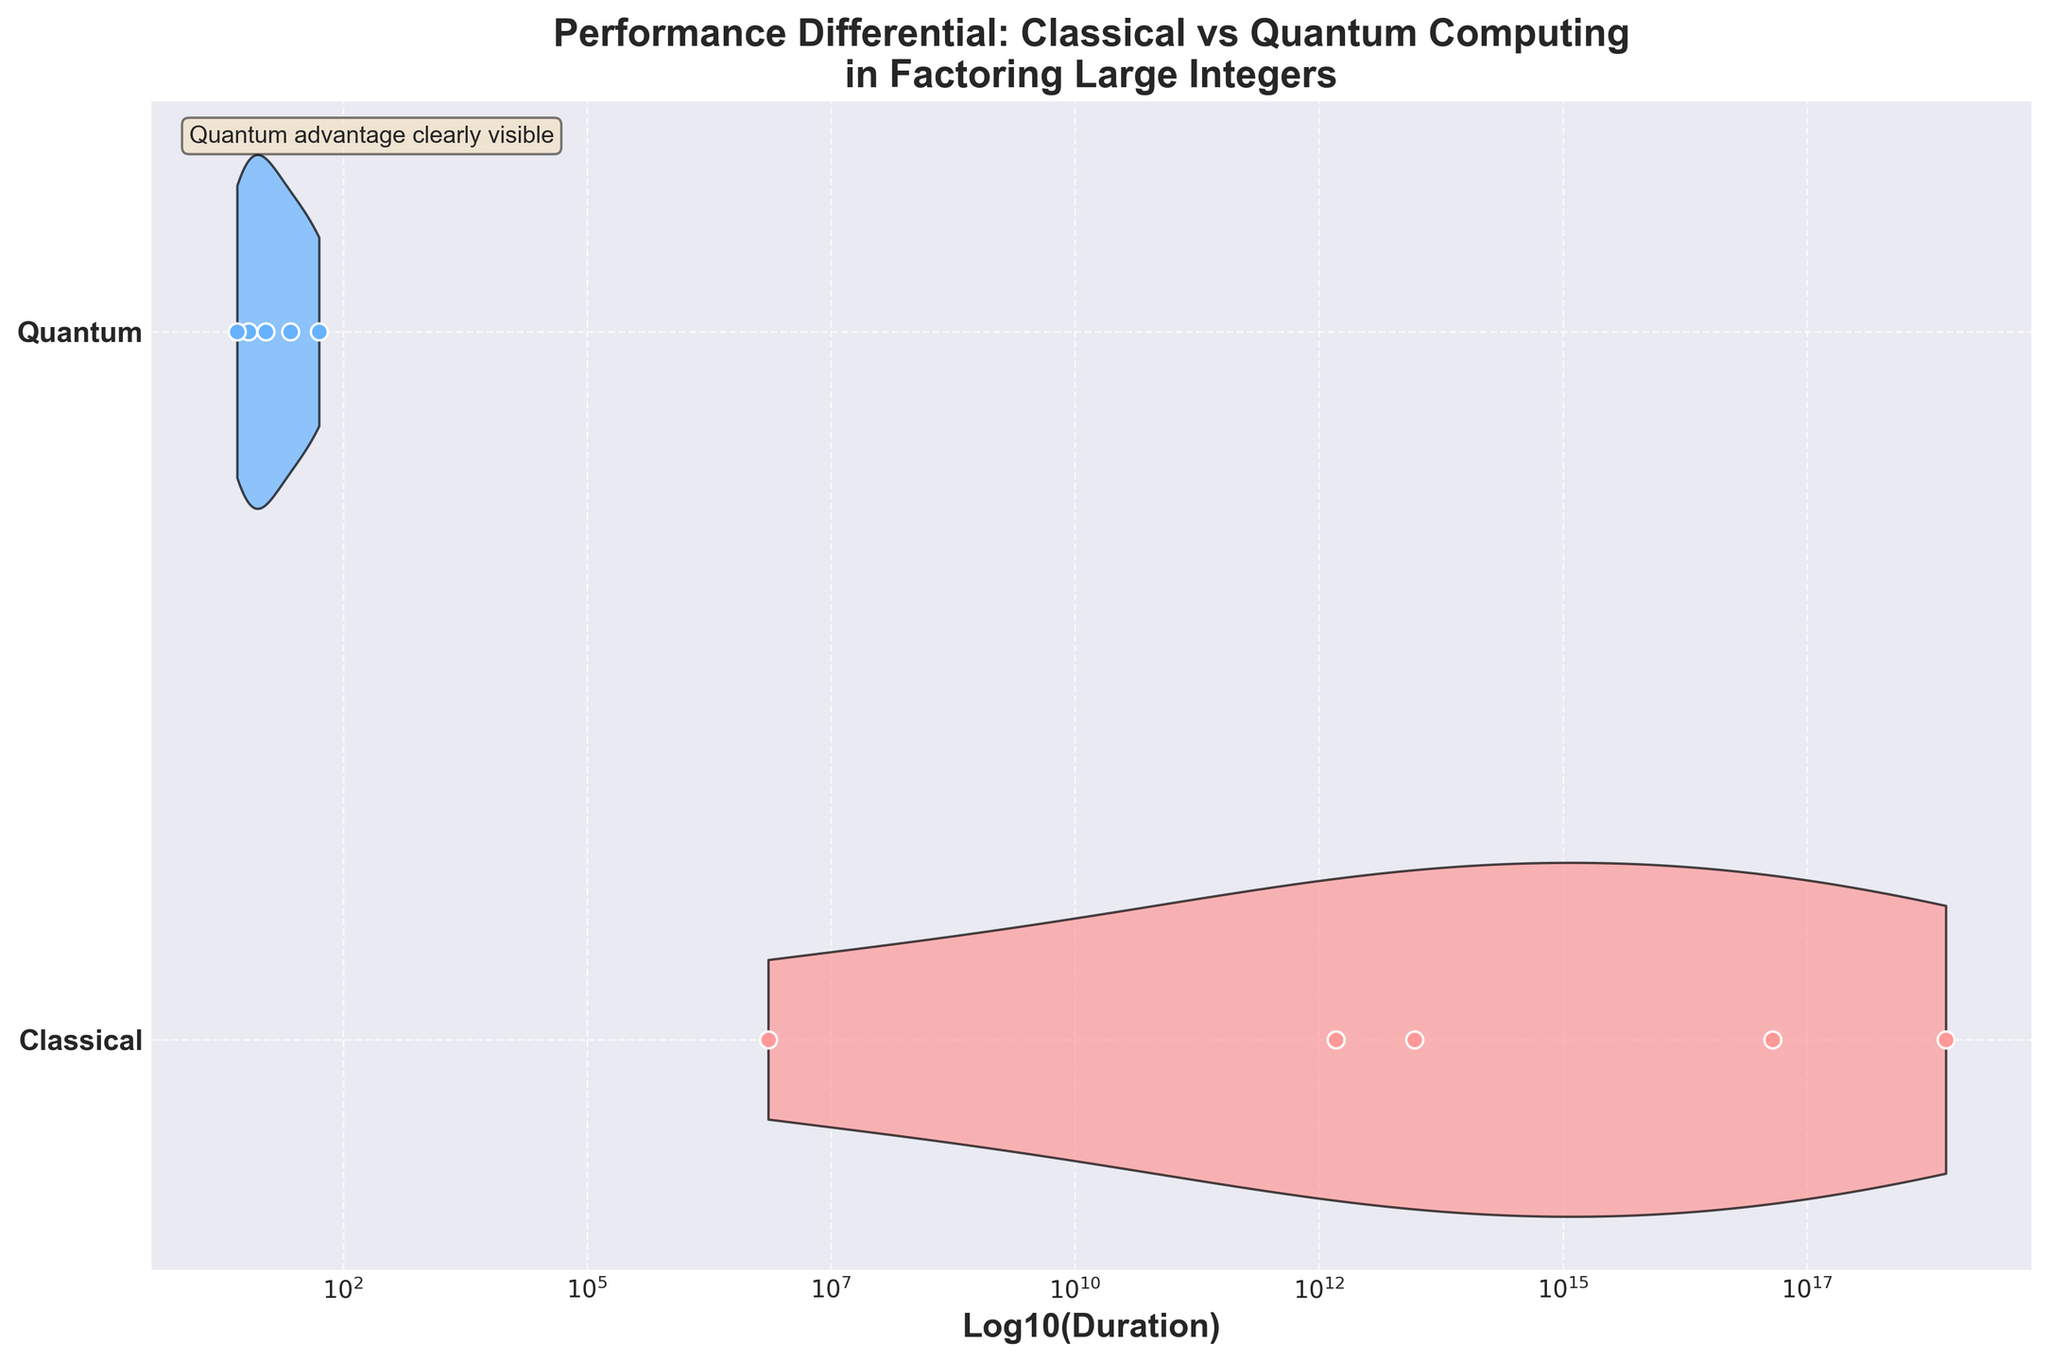What does the y-axis represent? The y-axis of the plot represents the two systems being compared: Classical and Quantum computing. Each system is assigned a specific position (1 for Classical, 2 for Quantum). The labels for these systems are marked on the y-axis.
Answer: Classical and Quantum systems What does the x-axis represent? The x-axis of the plot represents the logarithm (base 10) of the duration it takes for the systems to factor large integers. The values are shown in scientific notation for easier interpretation of large differences.
Answer: Logarithm of duration What colors are used to represent Classical and Quantum systems? The Classical system is represented by a light red (pinkish) color in the violin plot, while the Quantum system is represented by a light blue color. These colors help distinguish between the two systems easily.
Answer: Light red for Classical, light blue for Quantum Which system shows a clear advantage in factoring large integers, based on the plot? Based on the plot, the Quantum system has a clear advantage as the median log duration for Quantum computing is significantly lower than that for Classical computing, indicating that Quantum computing performs factoring much faster.
Answer: Quantum system How many distinct data points are represented for each system? Looking at the scatter plots overlaid on the violins, there are five distinct data points each for both Classical and Quantum systems.
Answer: Five for Classical, five for Quantum What is the range of log durations for the Classical system? The range of log durations for the Classical system can be seen from the scatter plot overlay on the violin. The lowest log duration is between 6 and 7, and the highest log duration is approximately 18.
Answer: Approximately 6 to 18 What is the approximate median duration for the Quantum system? The median duration for the Quantum system is where the bulk of the density of the violin plot is centered. It appears to be around 1.6 to 2 on the log scale.
Answer: 1.6 to 2 on the log scale How much faster is Quantum computing compared to Classical computing for factoring large integers? To contextualize this, consider the log duration ranges: the Quantum computing durations range around 1.5 to 2, while Classical computing durations are between 6 to 18. This indicates that Quantum computing can be many orders of magnitude faster than Classical computing, as 10^2 is vastly smaller than 10^6 or higher.
Answer: Orders of magnitude faster Which algorithm appears to benefit most from Quantum computing in terms of reduction in duration? Comparing the scatter plot data points, Shor's Algorithm sees the most reduction when moving from Classical to Quantum computing, significantly lowering the log duration required to factor large integers. This is evident from the substantially lower log duration values for Quantum systems.
Answer: Shor's Algorithm Is there any overlap in the duration ranges for Classical and Quantum systems? The violin plots show no overlap between the ranges of Classical and Quantum systems. The Quantum system durations are much lower, and log durations do not intersect with those of the Classical system.
Answer: No overlap 